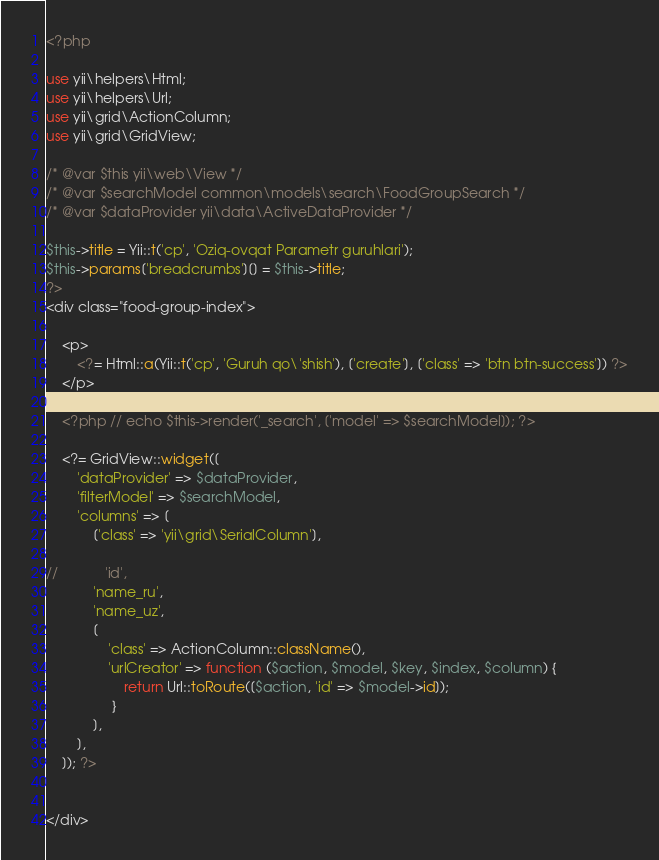Convert code to text. <code><loc_0><loc_0><loc_500><loc_500><_PHP_><?php

use yii\helpers\Html;
use yii\helpers\Url;
use yii\grid\ActionColumn;
use yii\grid\GridView;

/* @var $this yii\web\View */
/* @var $searchModel common\models\search\FoodGroupSearch */
/* @var $dataProvider yii\data\ActiveDataProvider */

$this->title = Yii::t('cp', 'Oziq-ovqat Parametr guruhlari');
$this->params['breadcrumbs'][] = $this->title;
?>
<div class="food-group-index">

    <p>
        <?= Html::a(Yii::t('cp', 'Guruh qo\'shish'), ['create'], ['class' => 'btn btn-success']) ?>
    </p>

    <?php // echo $this->render('_search', ['model' => $searchModel]); ?>

    <?= GridView::widget([
        'dataProvider' => $dataProvider,
        'filterModel' => $searchModel,
        'columns' => [
            ['class' => 'yii\grid\SerialColumn'],

//            'id',
            'name_ru',
            'name_uz',
            [
                'class' => ActionColumn::className(),
                'urlCreator' => function ($action, $model, $key, $index, $column) {
                    return Url::toRoute([$action, 'id' => $model->id]);
                 }
            ],
        ],
    ]); ?>


</div>
</code> 